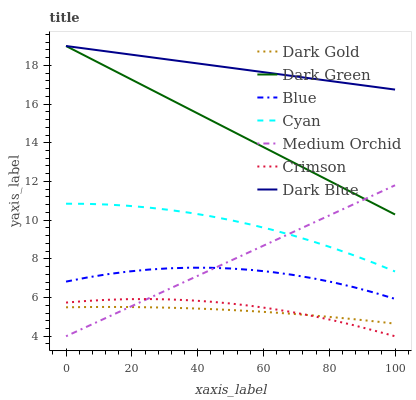Does Dark Gold have the minimum area under the curve?
Answer yes or no. Yes. Does Dark Blue have the maximum area under the curve?
Answer yes or no. Yes. Does Medium Orchid have the minimum area under the curve?
Answer yes or no. No. Does Medium Orchid have the maximum area under the curve?
Answer yes or no. No. Is Medium Orchid the smoothest?
Answer yes or no. Yes. Is Blue the roughest?
Answer yes or no. Yes. Is Dark Gold the smoothest?
Answer yes or no. No. Is Dark Gold the roughest?
Answer yes or no. No. Does Medium Orchid have the lowest value?
Answer yes or no. Yes. Does Dark Gold have the lowest value?
Answer yes or no. No. Does Dark Green have the highest value?
Answer yes or no. Yes. Does Medium Orchid have the highest value?
Answer yes or no. No. Is Crimson less than Dark Green?
Answer yes or no. Yes. Is Dark Blue greater than Crimson?
Answer yes or no. Yes. Does Medium Orchid intersect Blue?
Answer yes or no. Yes. Is Medium Orchid less than Blue?
Answer yes or no. No. Is Medium Orchid greater than Blue?
Answer yes or no. No. Does Crimson intersect Dark Green?
Answer yes or no. No. 